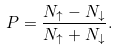<formula> <loc_0><loc_0><loc_500><loc_500>P = \frac { N _ { \uparrow } - N _ { \downarrow } } { N _ { \uparrow } + N _ { \downarrow } } .</formula> 